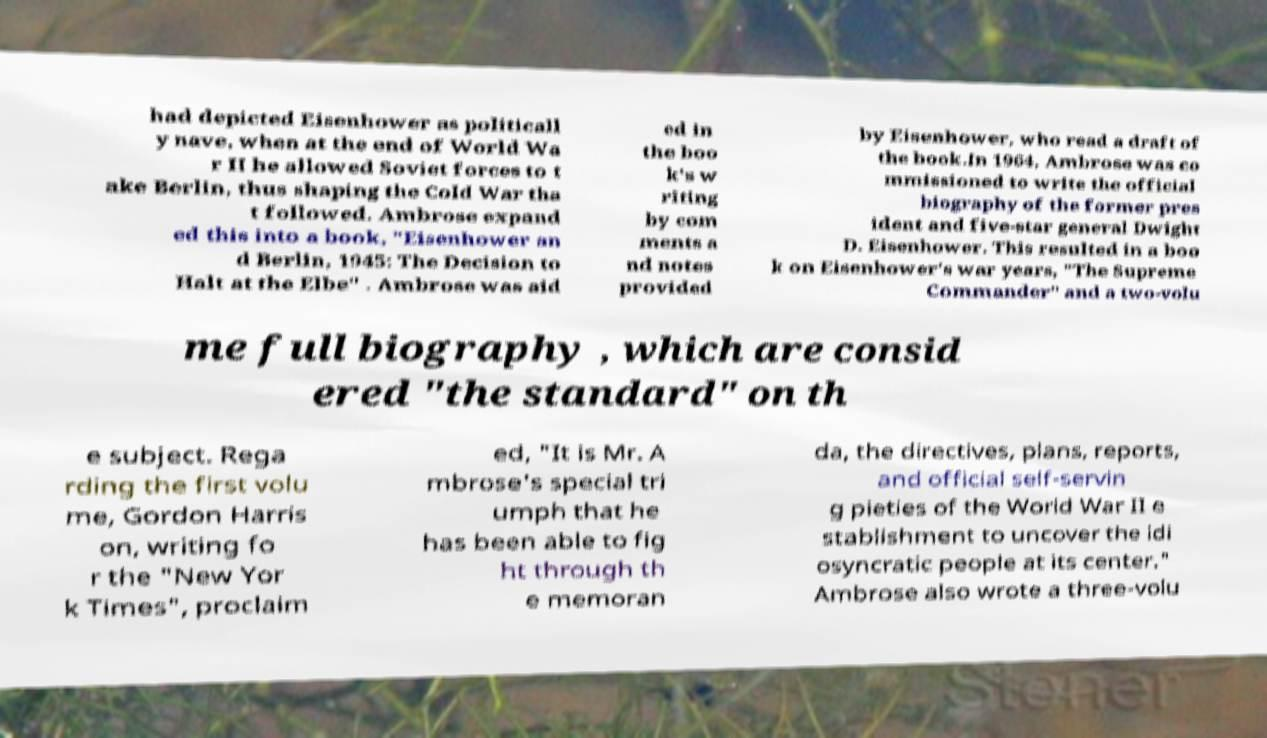Could you extract and type out the text from this image? had depicted Eisenhower as politicall y nave, when at the end of World Wa r II he allowed Soviet forces to t ake Berlin, thus shaping the Cold War tha t followed. Ambrose expand ed this into a book, "Eisenhower an d Berlin, 1945: The Decision to Halt at the Elbe" . Ambrose was aid ed in the boo k's w riting by com ments a nd notes provided by Eisenhower, who read a draft of the book.In 1964, Ambrose was co mmissioned to write the official biography of the former pres ident and five-star general Dwight D. Eisenhower. This resulted in a boo k on Eisenhower's war years, "The Supreme Commander" and a two-volu me full biography , which are consid ered "the standard" on th e subject. Rega rding the first volu me, Gordon Harris on, writing fo r the "New Yor k Times", proclaim ed, "It is Mr. A mbrose's special tri umph that he has been able to fig ht through th e memoran da, the directives, plans, reports, and official self-servin g pieties of the World War II e stablishment to uncover the idi osyncratic people at its center." Ambrose also wrote a three-volu 